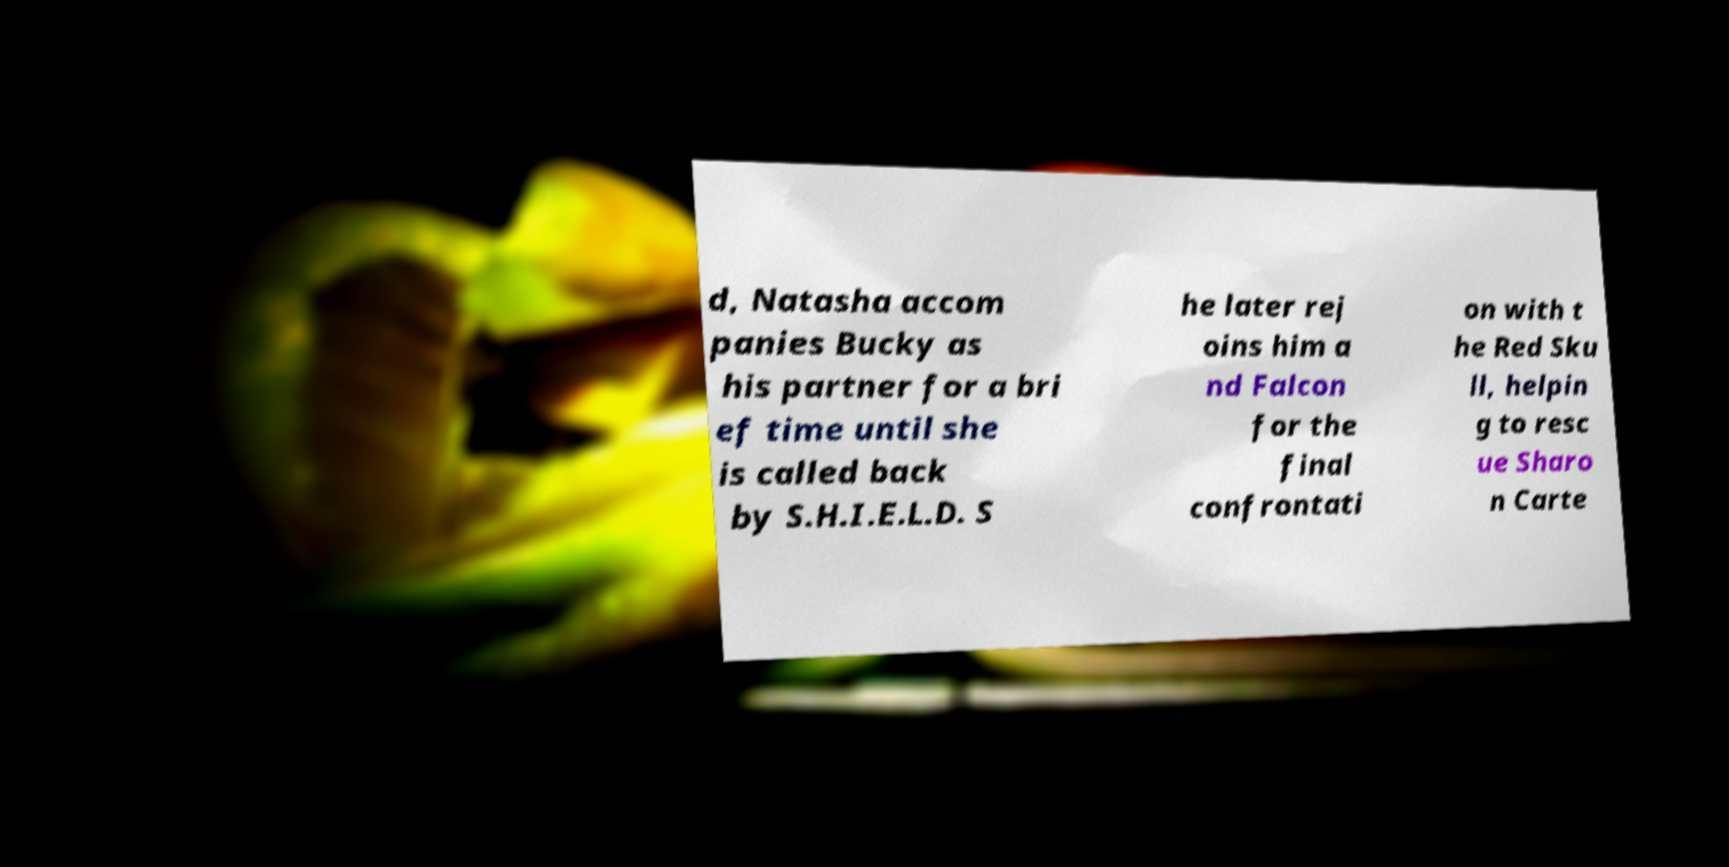Can you read and provide the text displayed in the image?This photo seems to have some interesting text. Can you extract and type it out for me? d, Natasha accom panies Bucky as his partner for a bri ef time until she is called back by S.H.I.E.L.D. S he later rej oins him a nd Falcon for the final confrontati on with t he Red Sku ll, helpin g to resc ue Sharo n Carte 